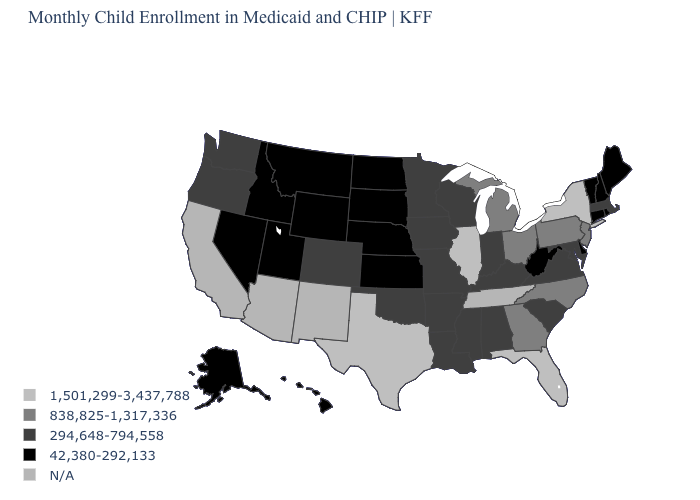Name the states that have a value in the range 838,825-1,317,336?
Quick response, please. Georgia, Michigan, New Jersey, North Carolina, Ohio, Pennsylvania. What is the value of Maine?
Give a very brief answer. 42,380-292,133. What is the value of Iowa?
Keep it brief. 294,648-794,558. How many symbols are there in the legend?
Quick response, please. 5. Does the map have missing data?
Write a very short answer. Yes. Name the states that have a value in the range 838,825-1,317,336?
Concise answer only. Georgia, Michigan, New Jersey, North Carolina, Ohio, Pennsylvania. Name the states that have a value in the range 1,501,299-3,437,788?
Be succinct. Florida, Illinois, New York, Texas. What is the highest value in the USA?
Give a very brief answer. 1,501,299-3,437,788. Name the states that have a value in the range 294,648-794,558?
Keep it brief. Alabama, Arkansas, Colorado, Indiana, Iowa, Kentucky, Louisiana, Maryland, Massachusetts, Minnesota, Mississippi, Missouri, Oklahoma, Oregon, South Carolina, Virginia, Washington, Wisconsin. Name the states that have a value in the range 838,825-1,317,336?
Short answer required. Georgia, Michigan, New Jersey, North Carolina, Ohio, Pennsylvania. What is the value of Mississippi?
Keep it brief. 294,648-794,558. Does the map have missing data?
Quick response, please. Yes. What is the value of Florida?
Answer briefly. 1,501,299-3,437,788. Among the states that border Arkansas , which have the lowest value?
Give a very brief answer. Louisiana, Mississippi, Missouri, Oklahoma. 